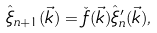Convert formula to latex. <formula><loc_0><loc_0><loc_500><loc_500>\hat { \xi } _ { n + 1 } ( \vec { k } ) = \check { f } ( \vec { k } ) \hat { \xi } ^ { \prime } _ { n } ( \vec { k } ) ,</formula> 